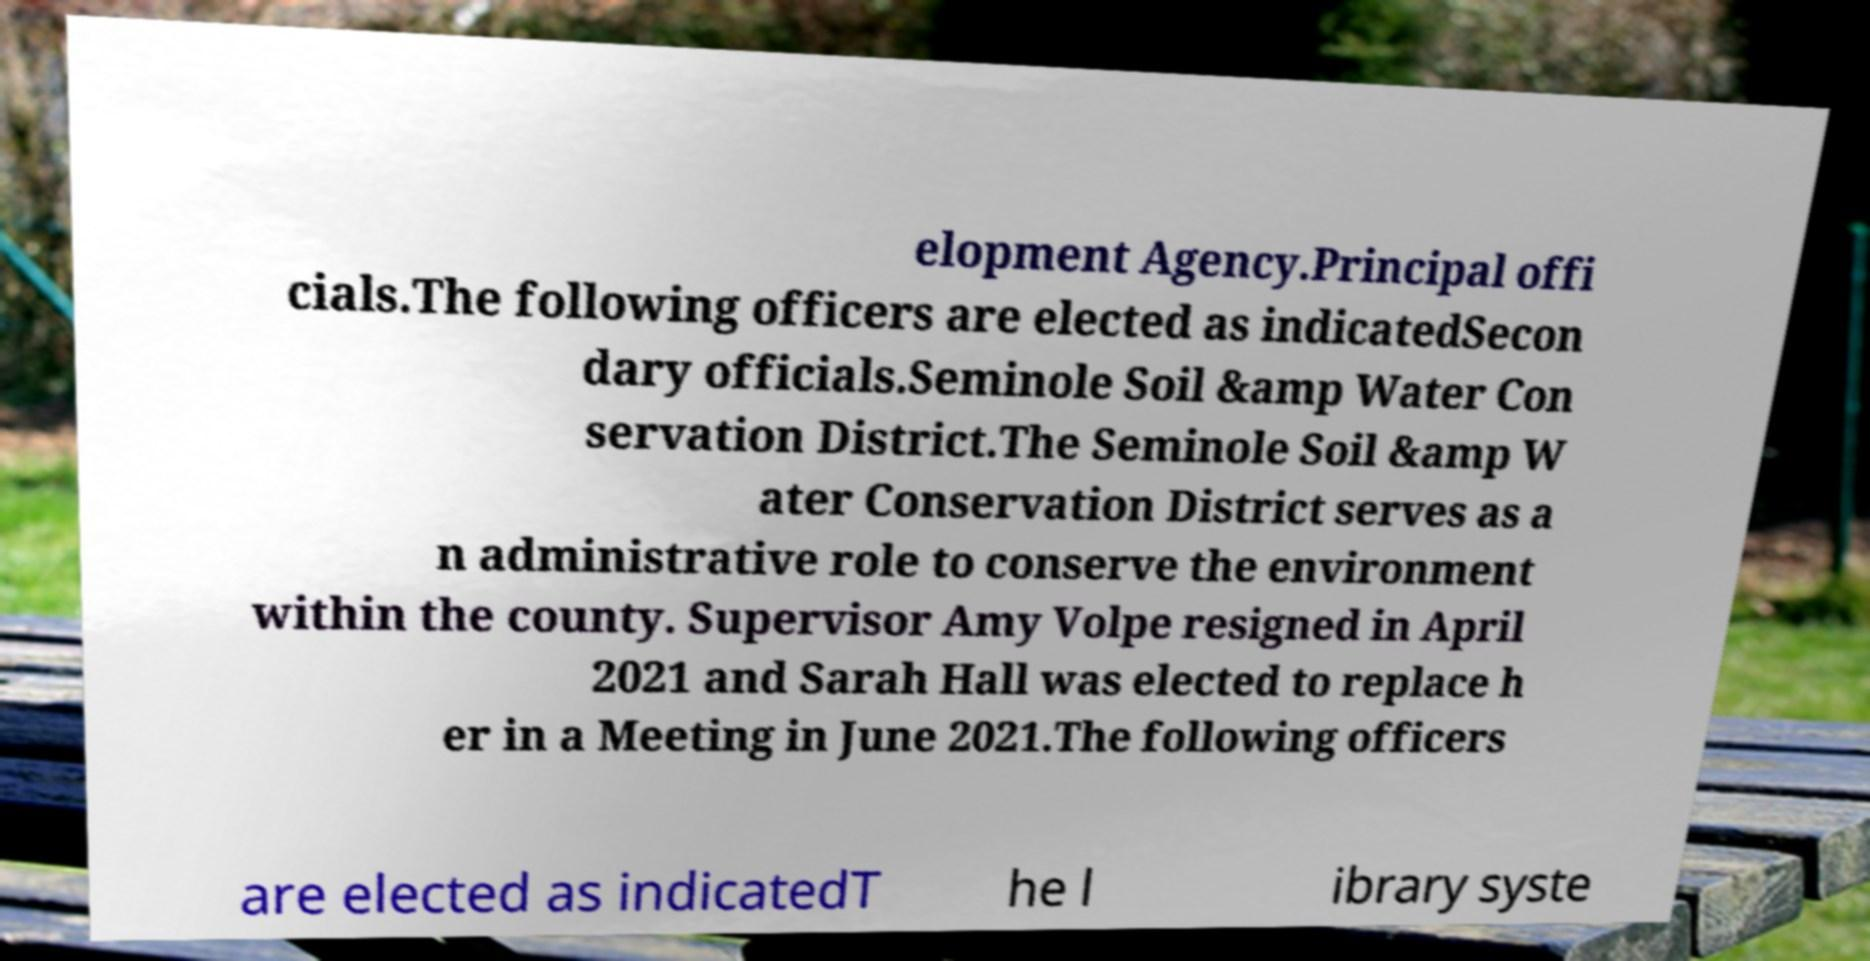For documentation purposes, I need the text within this image transcribed. Could you provide that? elopment Agency.Principal offi cials.The following officers are elected as indicatedSecon dary officials.Seminole Soil &amp Water Con servation District.The Seminole Soil &amp W ater Conservation District serves as a n administrative role to conserve the environment within the county. Supervisor Amy Volpe resigned in April 2021 and Sarah Hall was elected to replace h er in a Meeting in June 2021.The following officers are elected as indicatedT he l ibrary syste 